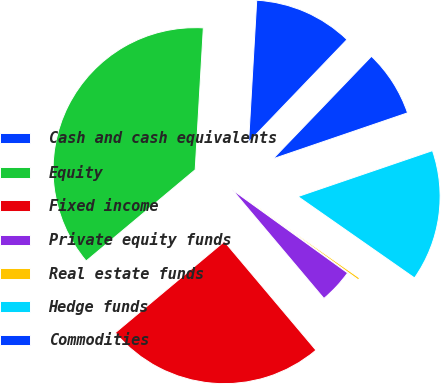<chart> <loc_0><loc_0><loc_500><loc_500><pie_chart><fcel>Cash and cash equivalents<fcel>Equity<fcel>Fixed income<fcel>Private equity funds<fcel>Real estate funds<fcel>Hedge funds<fcel>Commodities<nl><fcel>11.26%<fcel>37.0%<fcel>25.06%<fcel>3.91%<fcel>0.24%<fcel>14.94%<fcel>7.59%<nl></chart> 